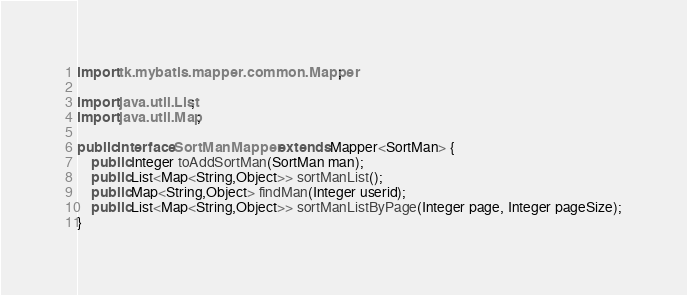Convert code to text. <code><loc_0><loc_0><loc_500><loc_500><_Java_>import tk.mybatis.mapper.common.Mapper;

import java.util.List;
import java.util.Map;

public interface SortManMapper extends Mapper<SortMan> {
    public Integer toAddSortMan(SortMan man);
    public List<Map<String,Object>> sortManList();
    public Map<String,Object> findMan(Integer userid);
    public List<Map<String,Object>> sortManListByPage(Integer page, Integer pageSize);
}</code> 